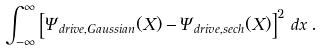Convert formula to latex. <formula><loc_0><loc_0><loc_500><loc_500>\int _ { - \infty } ^ { \infty } \left [ \Psi _ { d r i v e , G a u s s i a n } ( X ) - \Psi _ { d r i v e , s e c h } ( X ) \right ] ^ { 2 } \, d x \, .</formula> 